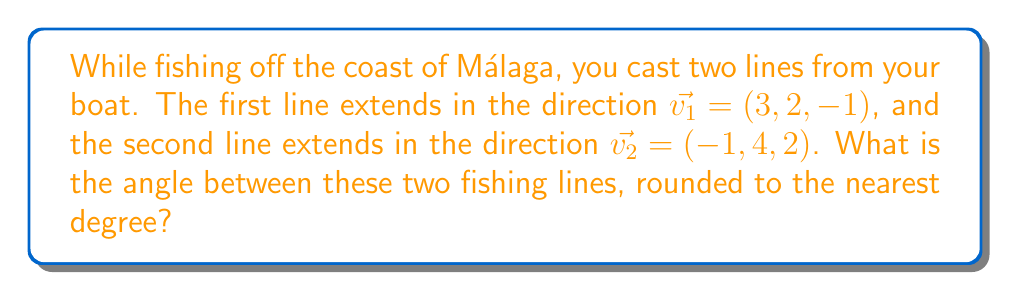Give your solution to this math problem. To find the angle between two vectors in 3D space, we can use the dot product formula:

$$\cos \theta = \frac{\vec{v_1} \cdot \vec{v_2}}{|\vec{v_1}| |\vec{v_2}|}$$

Step 1: Calculate the dot product $\vec{v_1} \cdot \vec{v_2}$
$$\vec{v_1} \cdot \vec{v_2} = (3)(-1) + (2)(4) + (-1)(2) = -3 + 8 - 2 = 3$$

Step 2: Calculate the magnitudes of $\vec{v_1}$ and $\vec{v_2}$
$$|\vec{v_1}| = \sqrt{3^2 + 2^2 + (-1)^2} = \sqrt{9 + 4 + 1} = \sqrt{14}$$
$$|\vec{v_2}| = \sqrt{(-1)^2 + 4^2 + 2^2} = \sqrt{1 + 16 + 4} = \sqrt{21}$$

Step 3: Apply the dot product formula
$$\cos \theta = \frac{3}{\sqrt{14} \cdot \sqrt{21}}$$

Step 4: Calculate $\theta$ using the inverse cosine function
$$\theta = \arccos\left(\frac{3}{\sqrt{14} \cdot \sqrt{21}}\right)$$

Step 5: Convert to degrees and round to the nearest degree
$$\theta \approx 80.36^\circ \approx 80^\circ$$
Answer: $80^\circ$ 